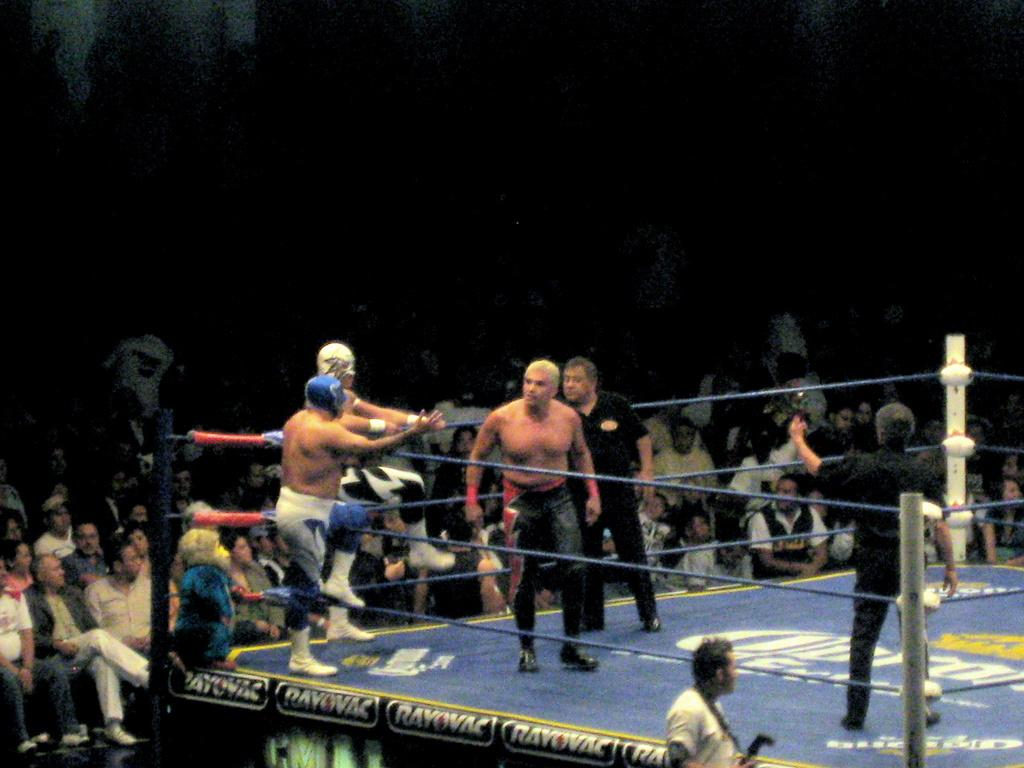What is happening in the center of the image? There is a group of people in a boxing ring. What can be seen in the foreground of the image? A person is holding a camera in the foreground. What is visible in the background of the image? There is an audience visible in the background. How many circles can be seen in the image? There is no specific mention of circles in the image, so it is not possible to determine the number of circles present. 